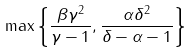<formula> <loc_0><loc_0><loc_500><loc_500>\max \left \{ \frac { \beta \gamma ^ { 2 } } { \gamma - 1 } , \frac { \alpha \delta ^ { 2 } } { \delta - \alpha - 1 } \right \}</formula> 